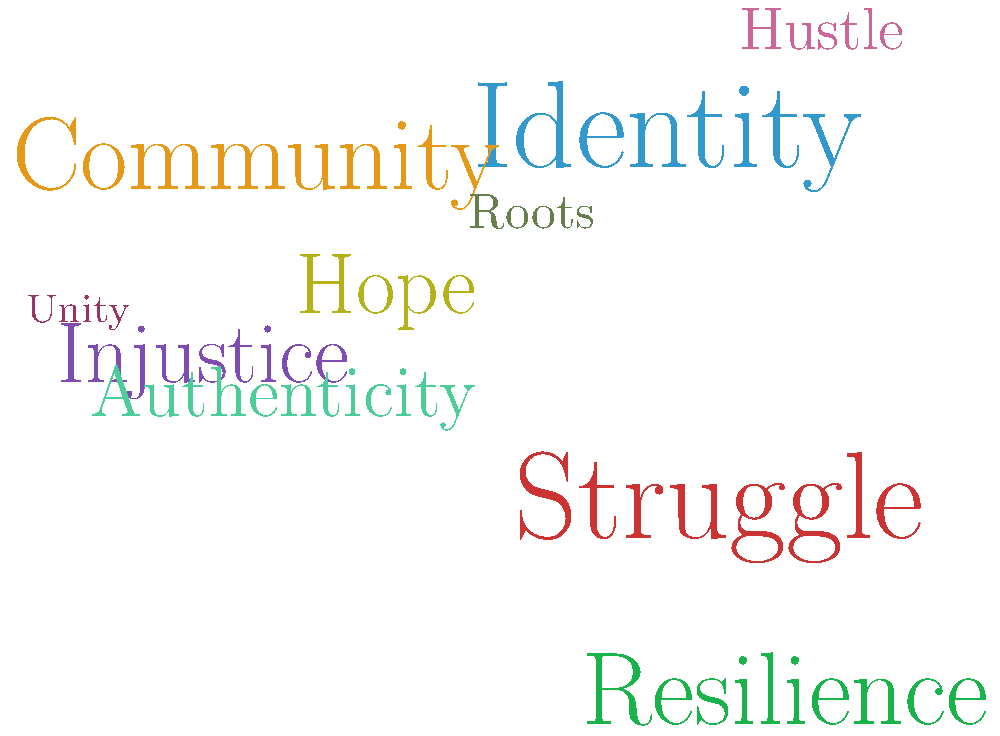Based on the word cloud representing the lyrical themes of an underground hip-hop album, what appears to be the central focus or message of the artist's work? To interpret the central focus or message of the artist's work based on this word cloud, we need to analyze the prominence and relationships of the words presented:

1. Identify the largest words: "Struggle" and "Identity" are the most prominent, suggesting they are key themes.

2. Look for related concepts: "Resilience" and "Hope" are also fairly large, which could be seen as responses to struggle.

3. Consider social context: "Community" and "Unity" appear, indicating a focus on collective experiences.

4. Note words related to social issues: "Injustice" is present, suggesting a critique of societal problems.

5. Observe authenticity markers: "Roots" and "Authenticity" point to a focus on genuine expression.

6. Recognize action-oriented words: "Hustle" implies a theme of perseverance and hard work.

7. Synthesize the overall message: The combination of these words suggests a narrative of personal and collective struggle against injustice, with an emphasis on maintaining identity and hope through community support and individual resilience.

Given the prominence of "Struggle" and "Identity," along with the supporting themes, the central focus appears to be on exploring and asserting identity in the face of adversity.
Answer: Identity and struggle in the face of adversity 